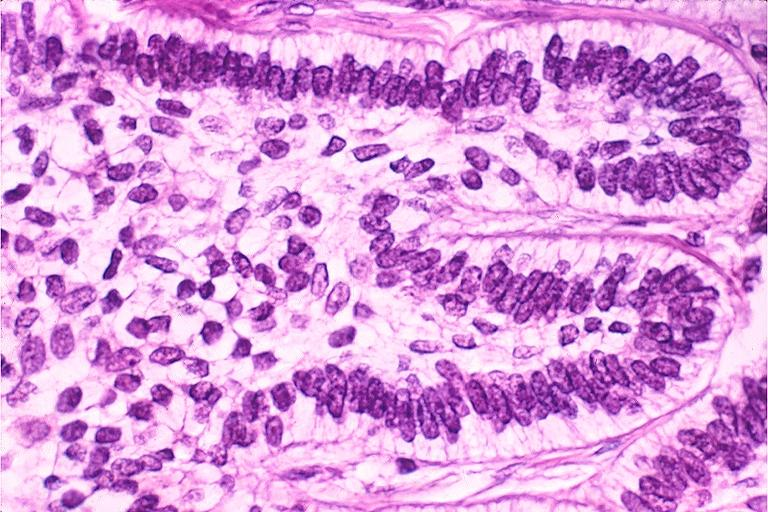s oral present?
Answer the question using a single word or phrase. Yes 